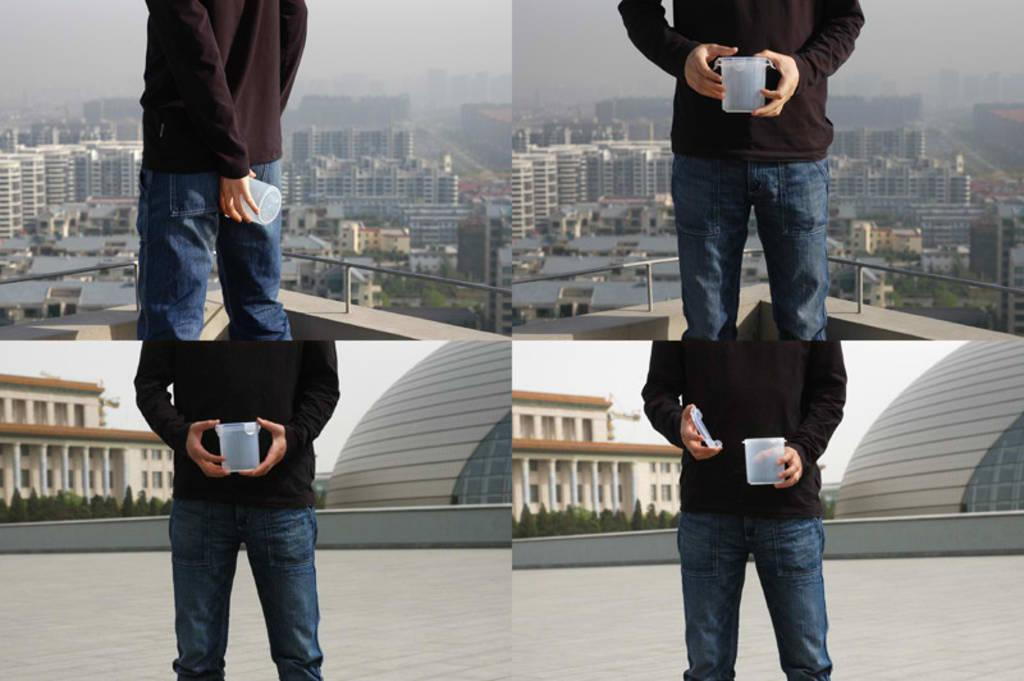How many images are combined in the collage? The collage is made up of 4 images. What is the person in one of the images doing? In one of the images, a person is holding a container. What type of natural elements can be seen in one of the images? In one of the images, there are plants visible. What type of man-made structure can be seen in one of the images? In one of the images, buildings are visible. What type of barrier can be seen in one of the images? In one of the images, a fence is present. How many people are in the crowd in the image? There is no crowd present in the image; it is a collage of 4 separate images. What type of wind can be seen in the image? There is no wind visible in the image, as the provided facts do not mention any weather conditions. 